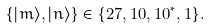Convert formula to latex. <formula><loc_0><loc_0><loc_500><loc_500>\{ | m \rangle , | n \rangle \} \in \{ 2 7 , 1 0 , 1 0 ^ { * } , 1 \} .</formula> 